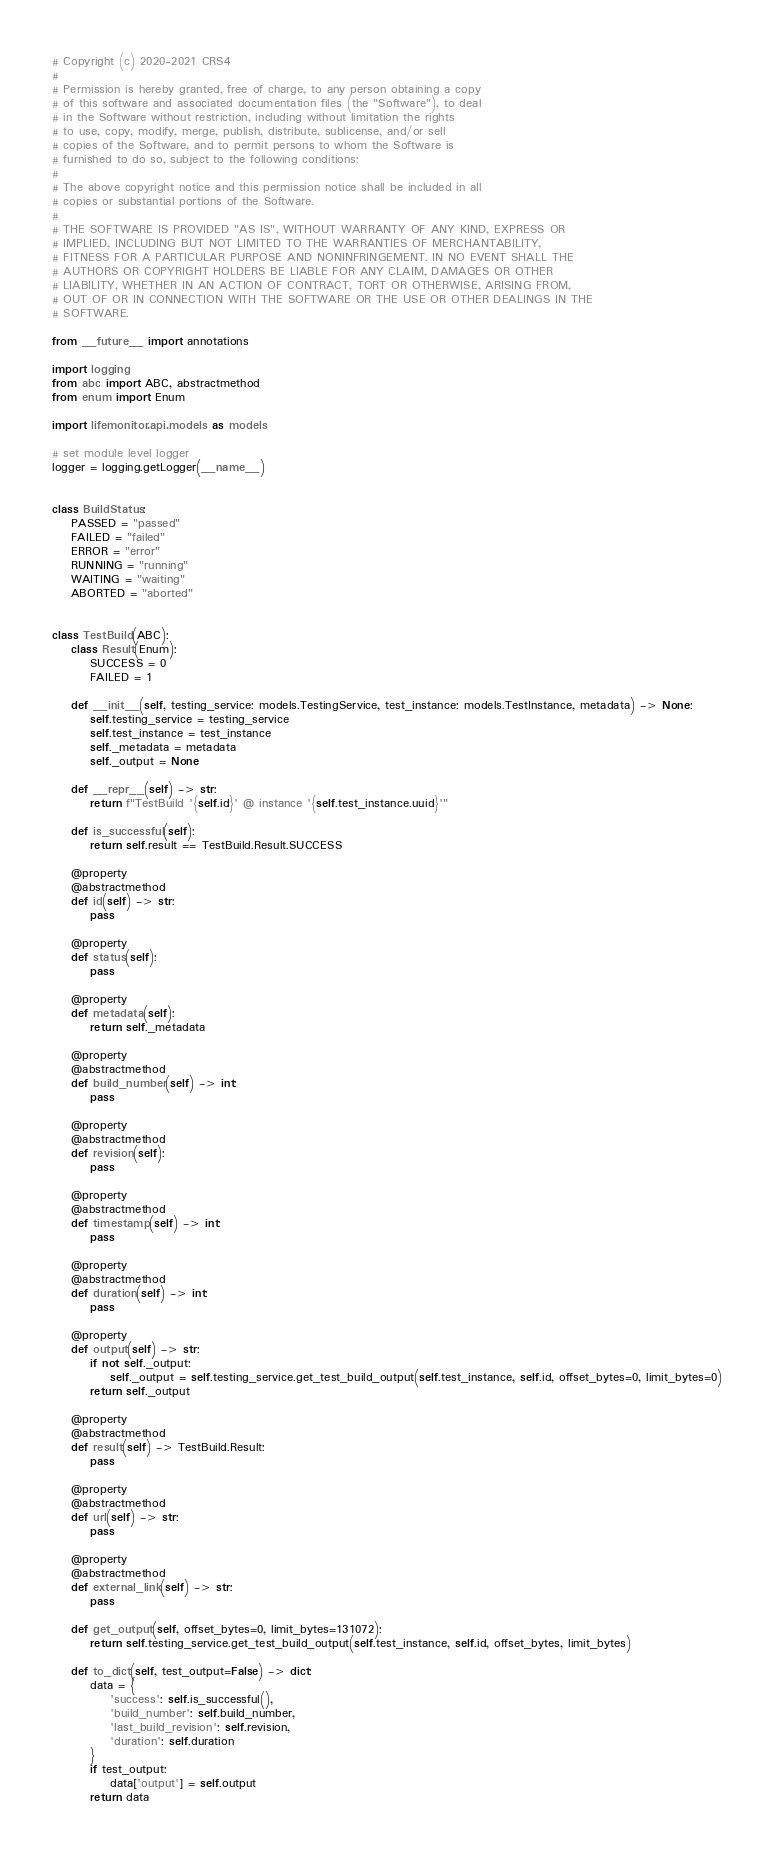<code> <loc_0><loc_0><loc_500><loc_500><_Python_># Copyright (c) 2020-2021 CRS4
#
# Permission is hereby granted, free of charge, to any person obtaining a copy
# of this software and associated documentation files (the "Software"), to deal
# in the Software without restriction, including without limitation the rights
# to use, copy, modify, merge, publish, distribute, sublicense, and/or sell
# copies of the Software, and to permit persons to whom the Software is
# furnished to do so, subject to the following conditions:
#
# The above copyright notice and this permission notice shall be included in all
# copies or substantial portions of the Software.
#
# THE SOFTWARE IS PROVIDED "AS IS", WITHOUT WARRANTY OF ANY KIND, EXPRESS OR
# IMPLIED, INCLUDING BUT NOT LIMITED TO THE WARRANTIES OF MERCHANTABILITY,
# FITNESS FOR A PARTICULAR PURPOSE AND NONINFRINGEMENT. IN NO EVENT SHALL THE
# AUTHORS OR COPYRIGHT HOLDERS BE LIABLE FOR ANY CLAIM, DAMAGES OR OTHER
# LIABILITY, WHETHER IN AN ACTION OF CONTRACT, TORT OR OTHERWISE, ARISING FROM,
# OUT OF OR IN CONNECTION WITH THE SOFTWARE OR THE USE OR OTHER DEALINGS IN THE
# SOFTWARE.

from __future__ import annotations

import logging
from abc import ABC, abstractmethod
from enum import Enum

import lifemonitor.api.models as models

# set module level logger
logger = logging.getLogger(__name__)


class BuildStatus:
    PASSED = "passed"
    FAILED = "failed"
    ERROR = "error"
    RUNNING = "running"
    WAITING = "waiting"
    ABORTED = "aborted"


class TestBuild(ABC):
    class Result(Enum):
        SUCCESS = 0
        FAILED = 1

    def __init__(self, testing_service: models.TestingService, test_instance: models.TestInstance, metadata) -> None:
        self.testing_service = testing_service
        self.test_instance = test_instance
        self._metadata = metadata
        self._output = None

    def __repr__(self) -> str:
        return f"TestBuild '{self.id}' @ instance '{self.test_instance.uuid}'"

    def is_successful(self):
        return self.result == TestBuild.Result.SUCCESS

    @property
    @abstractmethod
    def id(self) -> str:
        pass

    @property
    def status(self):
        pass

    @property
    def metadata(self):
        return self._metadata

    @property
    @abstractmethod
    def build_number(self) -> int:
        pass

    @property
    @abstractmethod
    def revision(self):
        pass

    @property
    @abstractmethod
    def timestamp(self) -> int:
        pass

    @property
    @abstractmethod
    def duration(self) -> int:
        pass

    @property
    def output(self) -> str:
        if not self._output:
            self._output = self.testing_service.get_test_build_output(self.test_instance, self.id, offset_bytes=0, limit_bytes=0)
        return self._output

    @property
    @abstractmethod
    def result(self) -> TestBuild.Result:
        pass

    @property
    @abstractmethod
    def url(self) -> str:
        pass

    @property
    @abstractmethod
    def external_link(self) -> str:
        pass

    def get_output(self, offset_bytes=0, limit_bytes=131072):
        return self.testing_service.get_test_build_output(self.test_instance, self.id, offset_bytes, limit_bytes)

    def to_dict(self, test_output=False) -> dict:
        data = {
            'success': self.is_successful(),
            'build_number': self.build_number,
            'last_build_revision': self.revision,
            'duration': self.duration
        }
        if test_output:
            data['output'] = self.output
        return data
</code> 